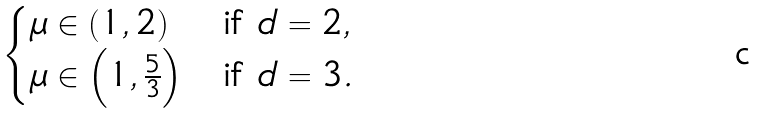Convert formula to latex. <formula><loc_0><loc_0><loc_500><loc_500>\begin{cases} \mu \in ( 1 , 2 ) & \text {if } d = 2 , \\ \mu \in \left ( 1 , \frac { 5 } { 3 } \right ) & \text {if } d = 3 . \end{cases}</formula> 